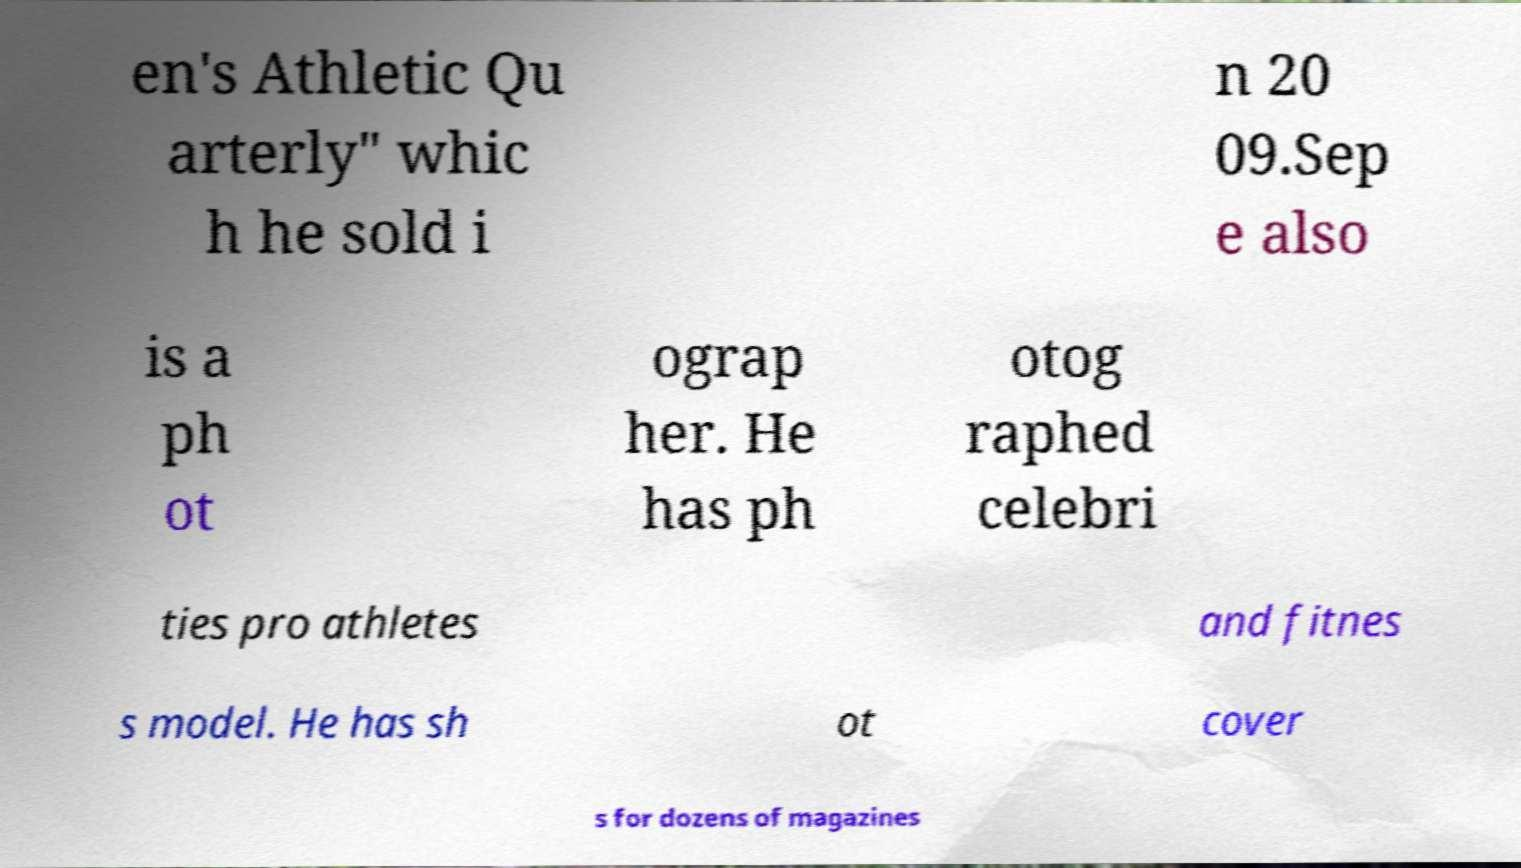I need the written content from this picture converted into text. Can you do that? en's Athletic Qu arterly" whic h he sold i n 20 09.Sep e also is a ph ot ograp her. He has ph otog raphed celebri ties pro athletes and fitnes s model. He has sh ot cover s for dozens of magazines 